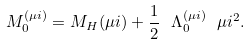Convert formula to latex. <formula><loc_0><loc_0><loc_500><loc_500>M _ { 0 } ^ { ( \mu i ) } = M _ { H } ( \mu i ) + \frac { 1 } { 2 } \ \Lambda _ { 0 } ^ { ( \mu i ) } \ \mu i ^ { 2 } .</formula> 